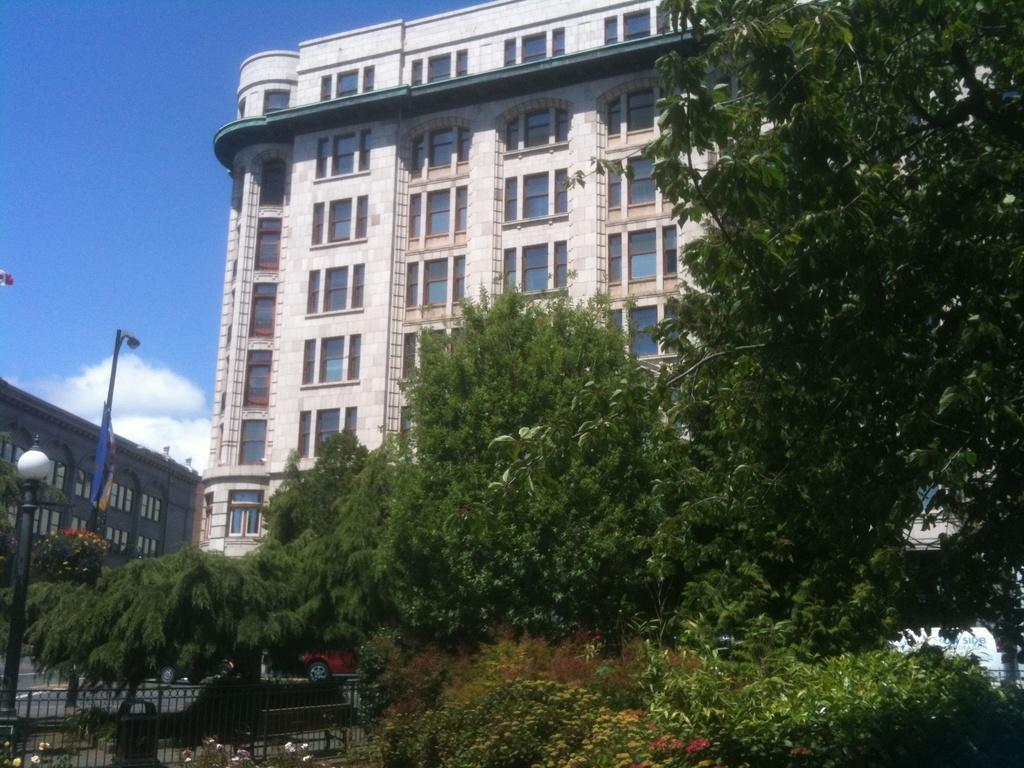Please provide a concise description of this image. In this image we can see trees, fence, cars on the road, light poles, banner, buildings and sky with clouds in the background. 